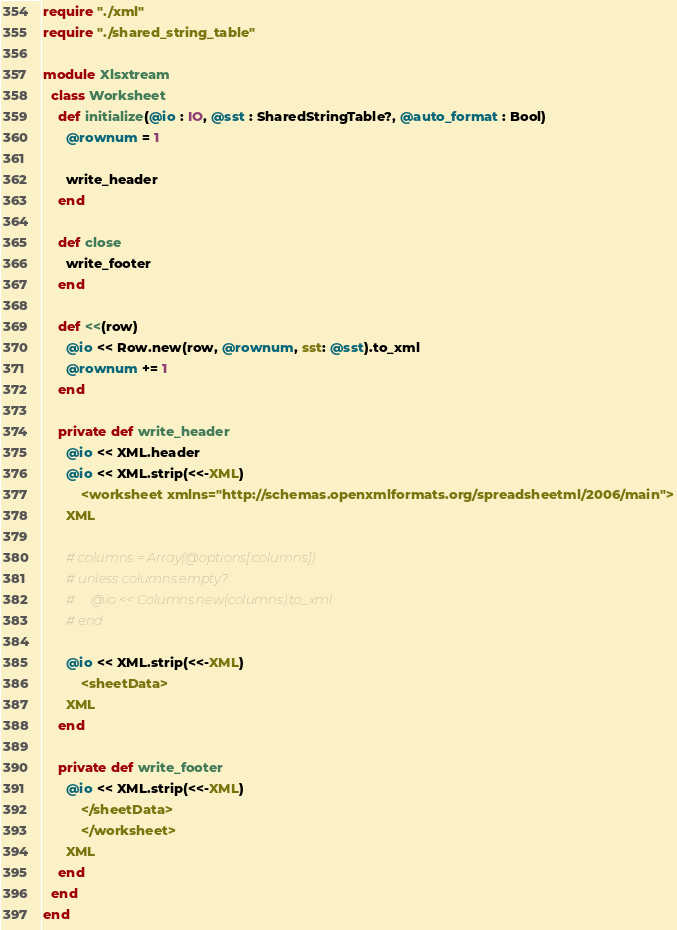<code> <loc_0><loc_0><loc_500><loc_500><_Crystal_>require "./xml"
require "./shared_string_table"

module Xlsxtream
  class Worksheet
    def initialize(@io : IO, @sst : SharedStringTable?, @auto_format : Bool)
      @rownum = 1

      write_header
    end

    def close
      write_footer
    end

    def <<(row)
      @io << Row.new(row, @rownum, sst: @sst).to_xml
      @rownum += 1
    end

    private def write_header
      @io << XML.header
      @io << XML.strip(<<-XML)
          <worksheet xmlns="http://schemas.openxmlformats.org/spreadsheetml/2006/main">
      XML

      # columns = Array(@options[:columns])
      # unless columns.empty?
      #     @io << Columns.new(columns).to_xml
      # end

      @io << XML.strip(<<-XML)
          <sheetData>
      XML
    end

    private def write_footer
      @io << XML.strip(<<-XML)
          </sheetData>
          </worksheet>
      XML
    end
  end
end
</code> 